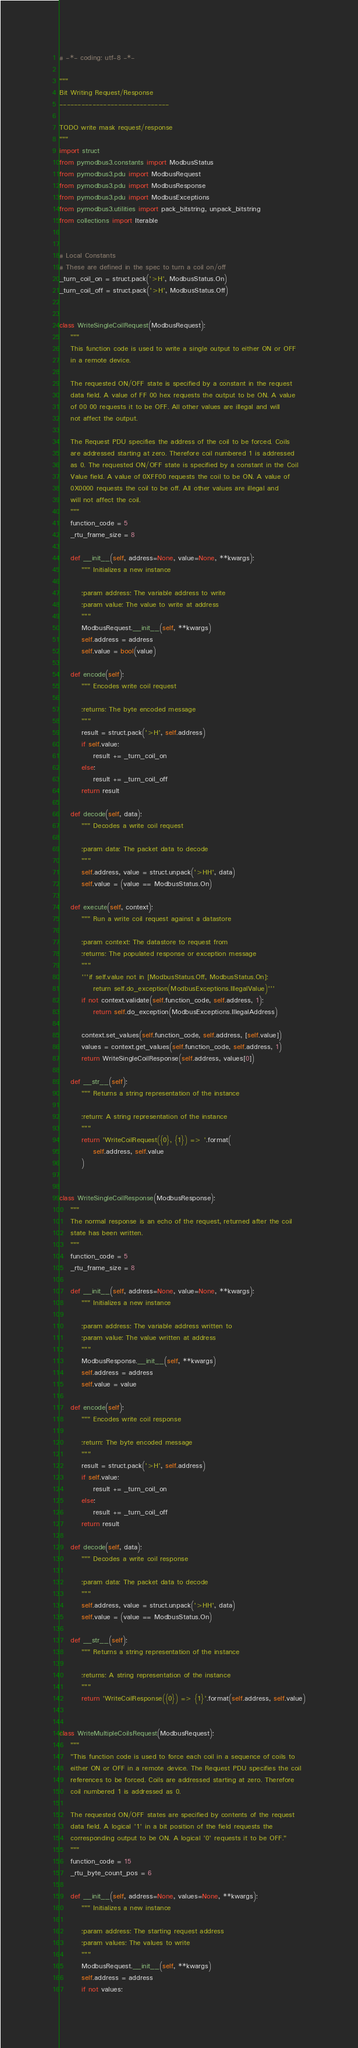Convert code to text. <code><loc_0><loc_0><loc_500><loc_500><_Python_># -*- coding: utf-8 -*-

"""
Bit Writing Request/Response
------------------------------

TODO write mask request/response
"""
import struct
from pymodbus3.constants import ModbusStatus
from pymodbus3.pdu import ModbusRequest
from pymodbus3.pdu import ModbusResponse
from pymodbus3.pdu import ModbusExceptions
from pymodbus3.utilities import pack_bitstring, unpack_bitstring
from collections import Iterable


# Local Constants
# These are defined in the spec to turn a coil on/off
_turn_coil_on = struct.pack('>H', ModbusStatus.On)
_turn_coil_off = struct.pack('>H', ModbusStatus.Off)


class WriteSingleCoilRequest(ModbusRequest):
    """
    This function code is used to write a single output to either ON or OFF
    in a remote device.

    The requested ON/OFF state is specified by a constant in the request
    data field. A value of FF 00 hex requests the output to be ON. A value
    of 00 00 requests it to be OFF. All other values are illegal and will
    not affect the output.

    The Request PDU specifies the address of the coil to be forced. Coils
    are addressed starting at zero. Therefore coil numbered 1 is addressed
    as 0. The requested ON/OFF state is specified by a constant in the Coil
    Value field. A value of 0XFF00 requests the coil to be ON. A value of
    0X0000 requests the coil to be off. All other values are illegal and
    will not affect the coil.
    """
    function_code = 5
    _rtu_frame_size = 8

    def __init__(self, address=None, value=None, **kwargs):
        """ Initializes a new instance

        :param address: The variable address to write
        :param value: The value to write at address
        """
        ModbusRequest.__init__(self, **kwargs)
        self.address = address
        self.value = bool(value)

    def encode(self):
        """ Encodes write coil request

        :returns: The byte encoded message
        """
        result = struct.pack('>H', self.address)
        if self.value:
            result += _turn_coil_on
        else:
            result += _turn_coil_off
        return result

    def decode(self, data):
        """ Decodes a write coil request

        :param data: The packet data to decode
        """
        self.address, value = struct.unpack('>HH', data)
        self.value = (value == ModbusStatus.On)

    def execute(self, context):
        """ Run a write coil request against a datastore

        :param context: The datastore to request from
        :returns: The populated response or exception message
        """
        '''if self.value not in [ModbusStatus.Off, ModbusStatus.On]:
            return self.do_exception(ModbusExceptions.IllegalValue)'''
        if not context.validate(self.function_code, self.address, 1):
            return self.do_exception(ModbusExceptions.IllegalAddress)

        context.set_values(self.function_code, self.address, [self.value])
        values = context.get_values(self.function_code, self.address, 1)
        return WriteSingleCoilResponse(self.address, values[0])

    def __str__(self):
        """ Returns a string representation of the instance

        :return: A string representation of the instance
        """
        return 'WriteCoilRequest({0}, {1}) => '.format(
            self.address, self.value
        )


class WriteSingleCoilResponse(ModbusResponse):
    """
    The normal response is an echo of the request, returned after the coil
    state has been written.
    """
    function_code = 5
    _rtu_frame_size = 8

    def __init__(self, address=None, value=None, **kwargs):
        """ Initializes a new instance

        :param address: The variable address written to
        :param value: The value written at address
        """
        ModbusResponse.__init__(self, **kwargs)
        self.address = address
        self.value = value

    def encode(self):
        """ Encodes write coil response

        :return: The byte encoded message
        """
        result = struct.pack('>H', self.address)
        if self.value:
            result += _turn_coil_on
        else:
            result += _turn_coil_off
        return result

    def decode(self, data):
        """ Decodes a write coil response

        :param data: The packet data to decode
        """
        self.address, value = struct.unpack('>HH', data)
        self.value = (value == ModbusStatus.On)

    def __str__(self):
        """ Returns a string representation of the instance

        :returns: A string representation of the instance
        """
        return 'WriteCoilResponse({0}) => {1}'.format(self.address, self.value)


class WriteMultipleCoilsRequest(ModbusRequest):
    """
    "This function code is used to force each coil in a sequence of coils to
    either ON or OFF in a remote device. The Request PDU specifies the coil
    references to be forced. Coils are addressed starting at zero. Therefore
    coil numbered 1 is addressed as 0.

    The requested ON/OFF states are specified by contents of the request
    data field. A logical '1' in a bit position of the field requests the
    corresponding output to be ON. A logical '0' requests it to be OFF."
    """
    function_code = 15
    _rtu_byte_count_pos = 6

    def __init__(self, address=None, values=None, **kwargs):
        """ Initializes a new instance

        :param address: The starting request address
        :param values: The values to write
        """
        ModbusRequest.__init__(self, **kwargs)
        self.address = address
        if not values:</code> 